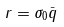<formula> <loc_0><loc_0><loc_500><loc_500>r = \sigma _ { 0 } \bar { q }</formula> 